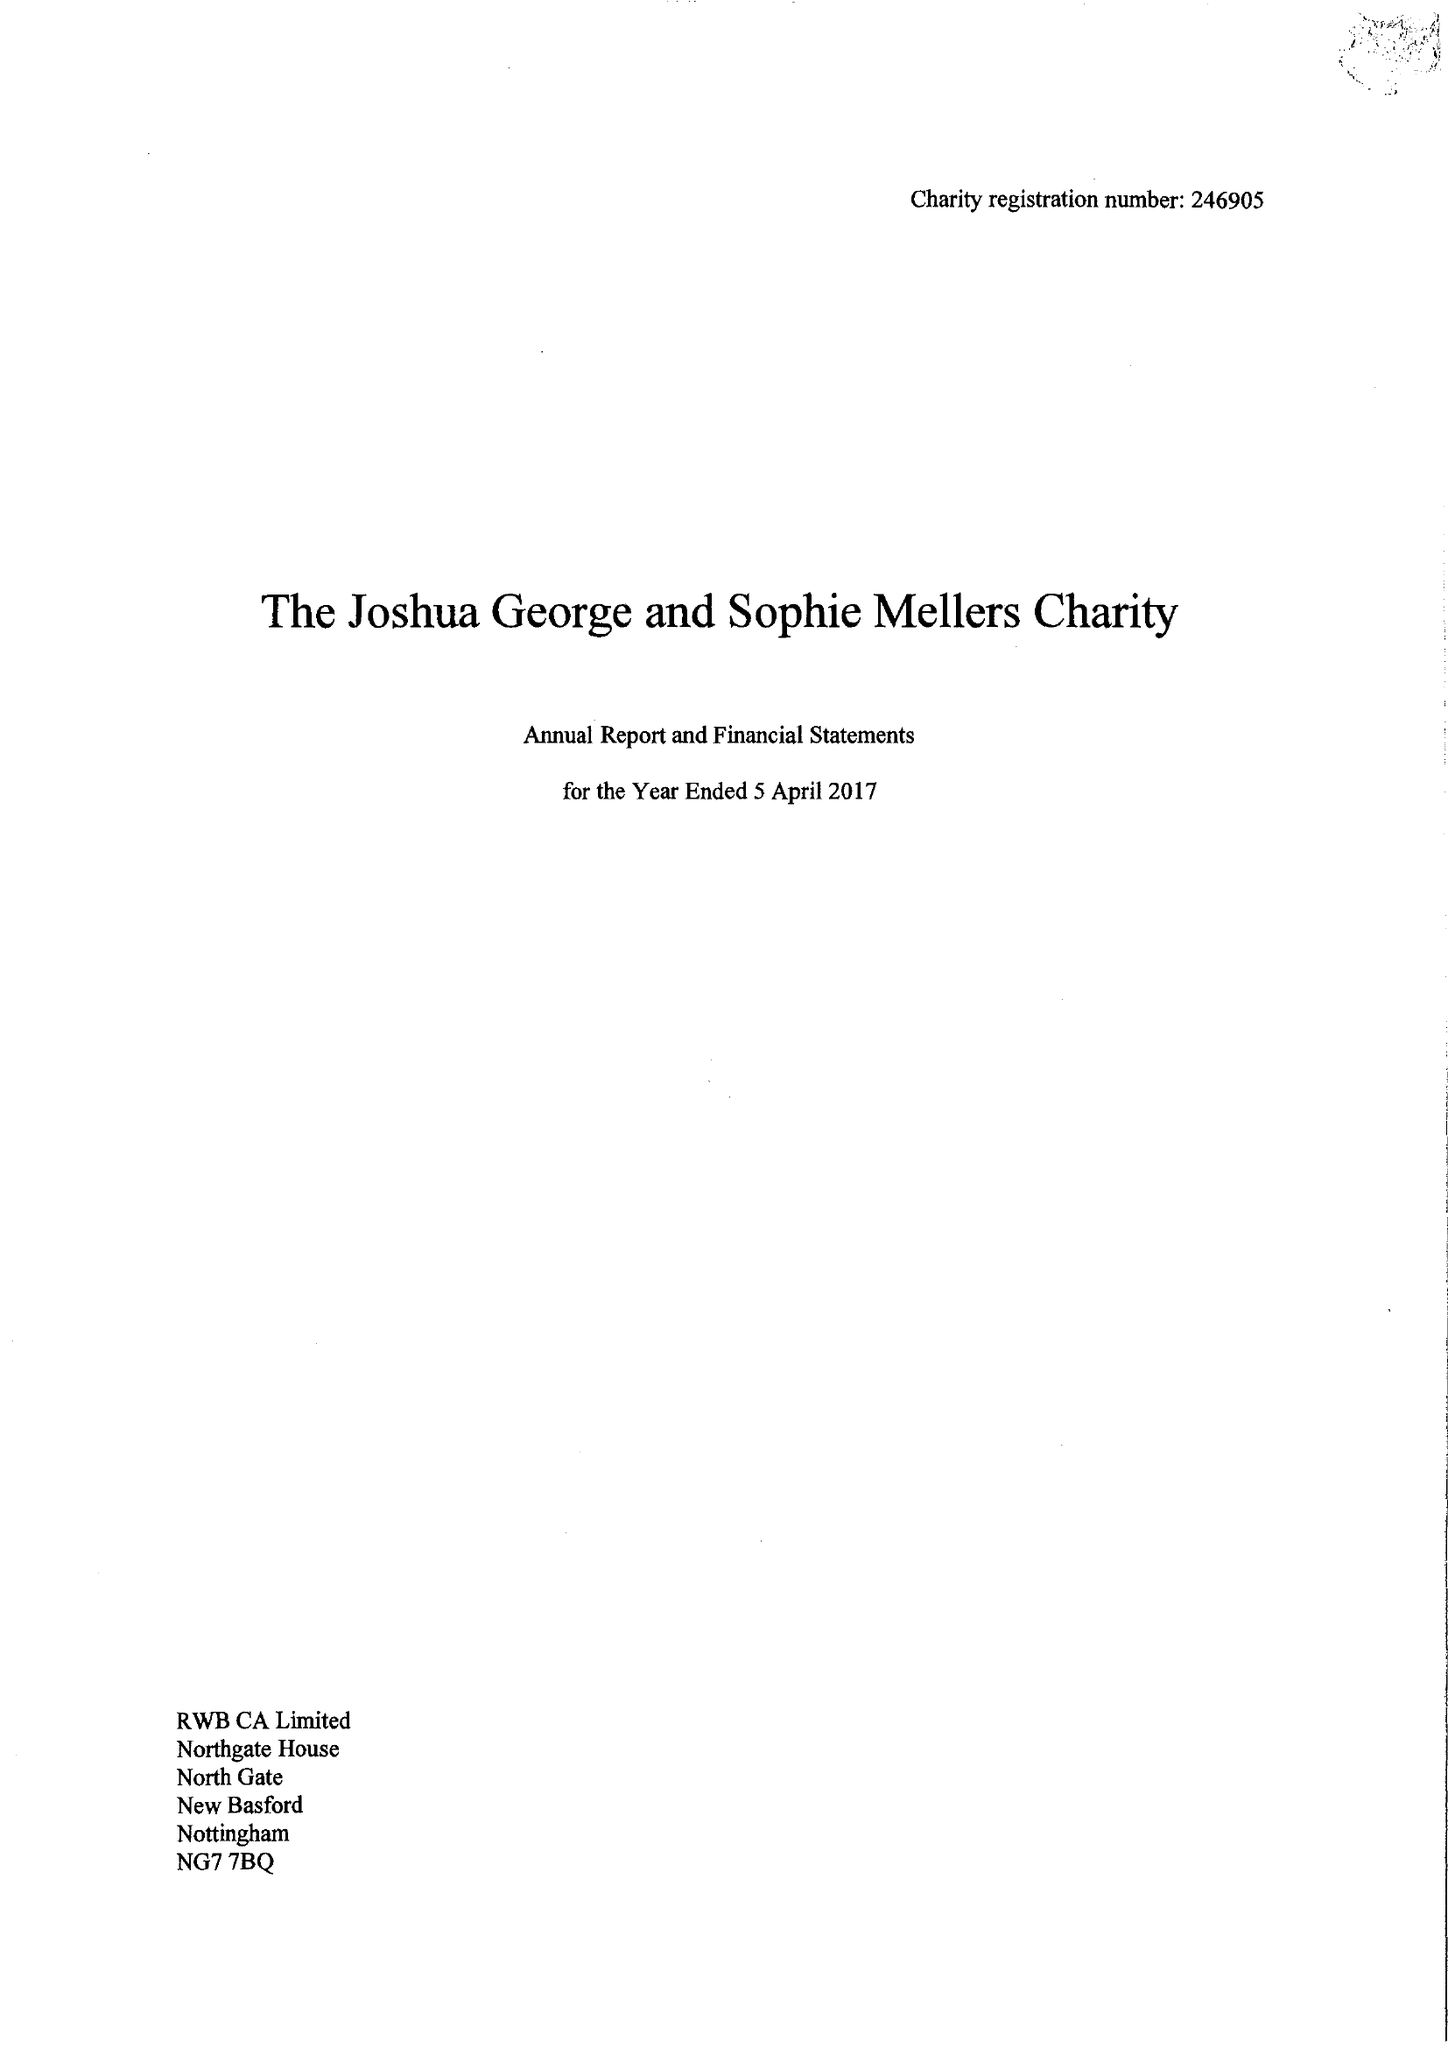What is the value for the charity_name?
Answer the question using a single word or phrase. The Joshua George and Sophie Mellers Charity 